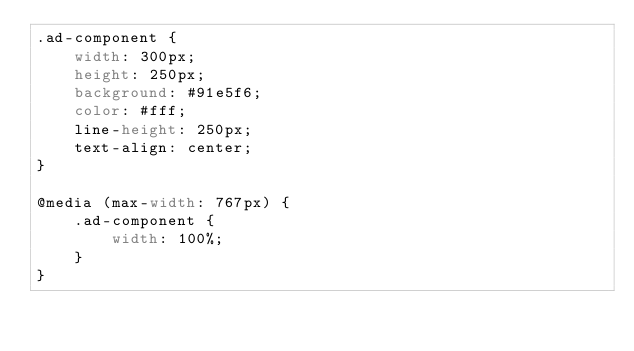<code> <loc_0><loc_0><loc_500><loc_500><_CSS_>.ad-component {
    width: 300px;
    height: 250px;
    background: #91e5f6;
    color: #fff;
    line-height: 250px;
    text-align: center;
}

@media (max-width: 767px) {
    .ad-component {
        width: 100%;
    }
}</code> 